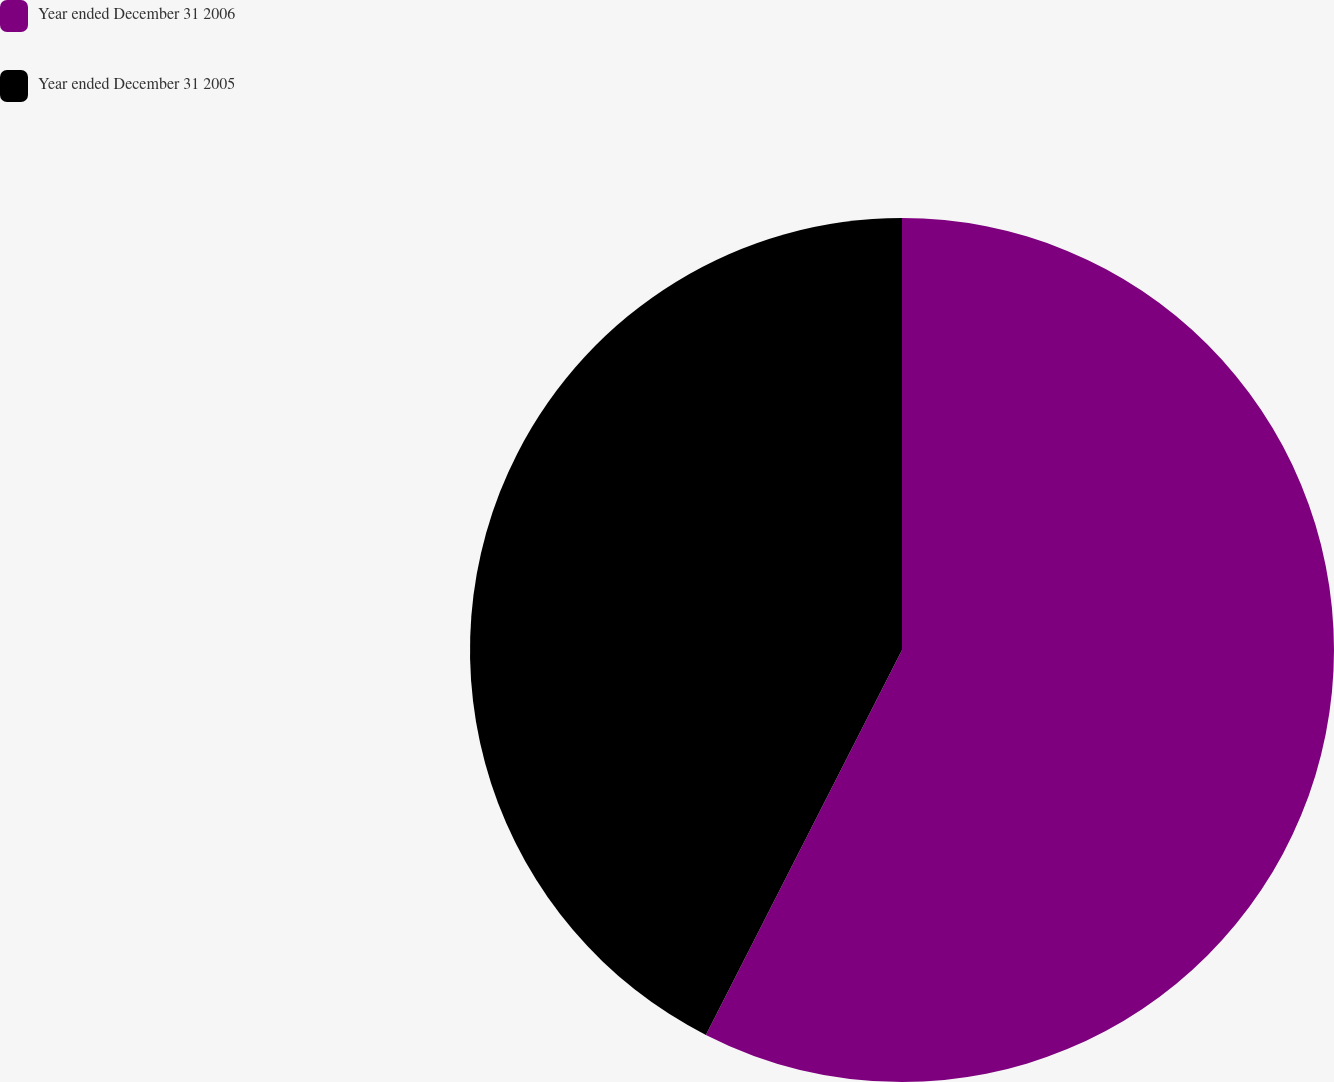<chart> <loc_0><loc_0><loc_500><loc_500><pie_chart><fcel>Year ended December 31 2006<fcel>Year ended December 31 2005<nl><fcel>57.5%<fcel>42.5%<nl></chart> 